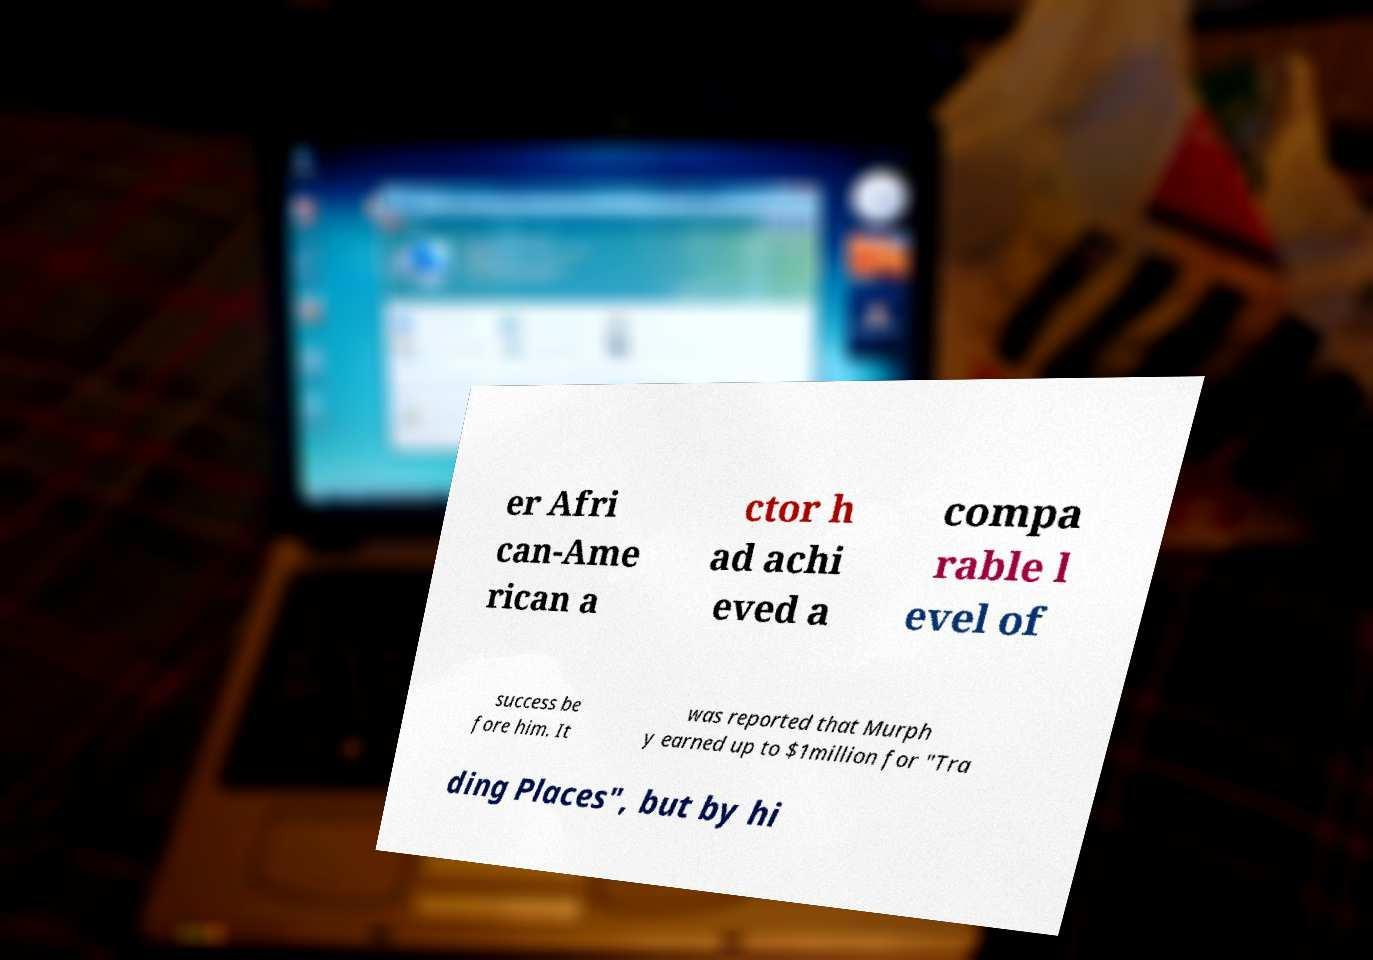Please identify and transcribe the text found in this image. er Afri can-Ame rican a ctor h ad achi eved a compa rable l evel of success be fore him. It was reported that Murph y earned up to $1million for "Tra ding Places", but by hi 